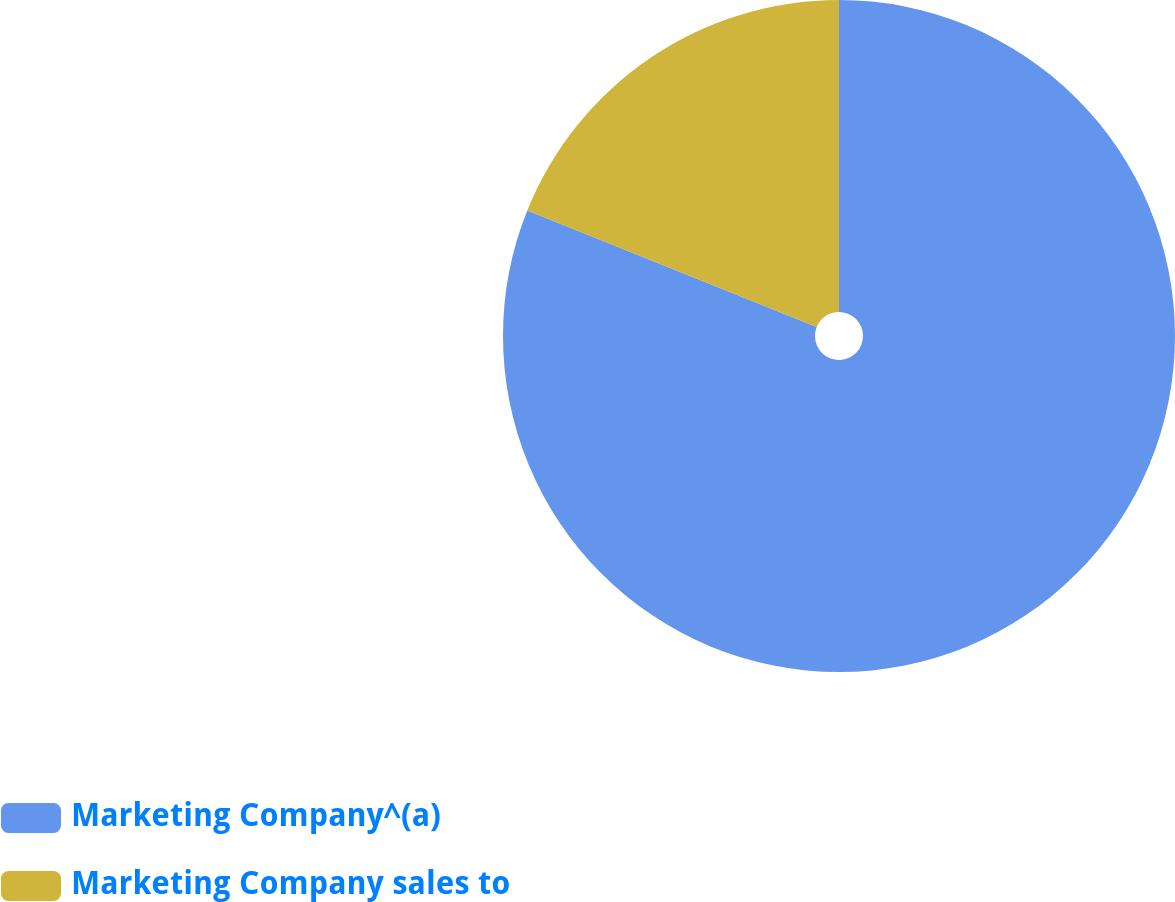<chart> <loc_0><loc_0><loc_500><loc_500><pie_chart><fcel>Marketing Company^(a)<fcel>Marketing Company sales to<nl><fcel>81.09%<fcel>18.91%<nl></chart> 